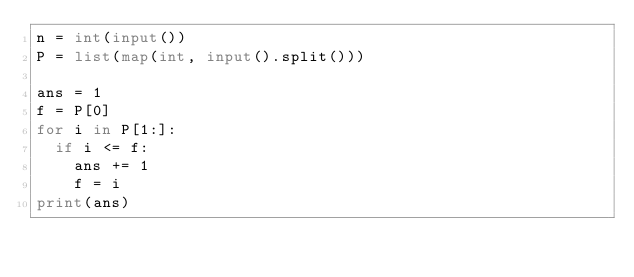<code> <loc_0><loc_0><loc_500><loc_500><_Python_>n = int(input())
P = list(map(int, input().split()))

ans = 1
f = P[0]
for i in P[1:]:
  if i <= f:
    ans += 1
    f = i
print(ans)
</code> 